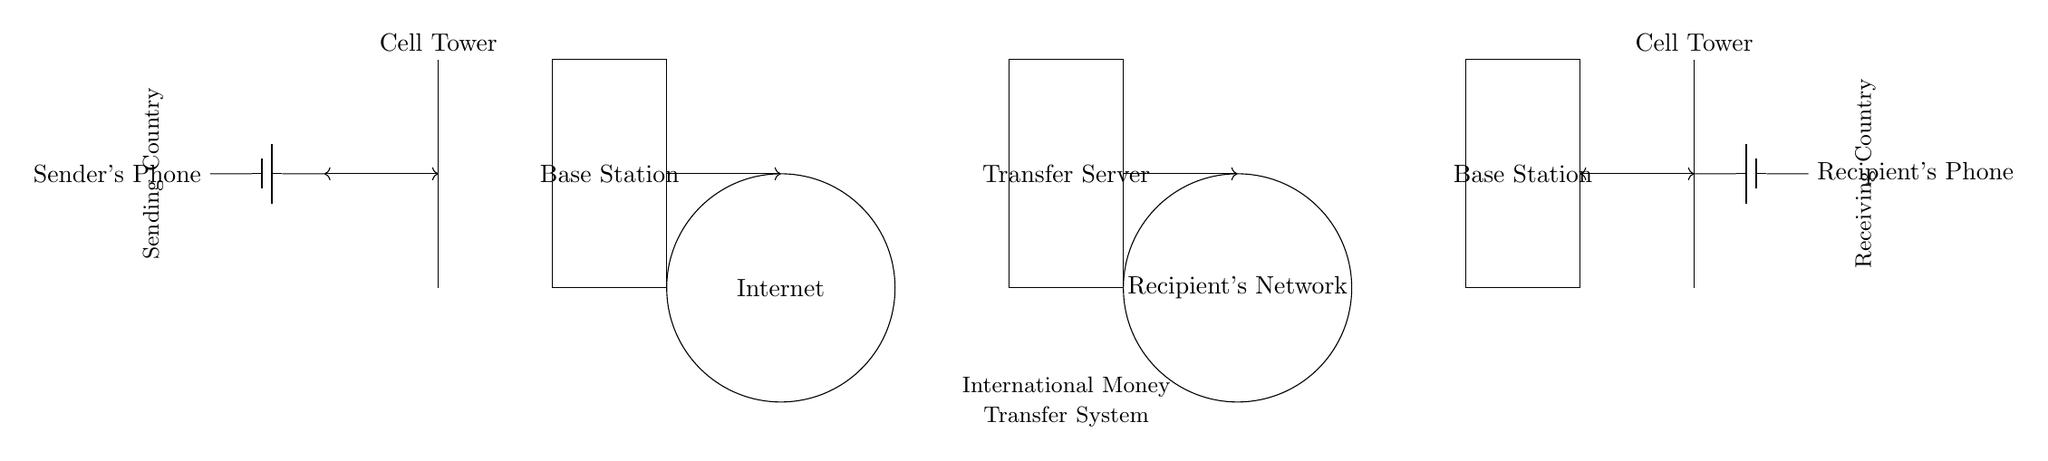What is at the leftmost part of the circuit? The leftmost part of the circuit features the sender's phone connected to a battery, which supplies power for sending signals.
Answer: Sender's Phone What is in the center of the circuit diagram? In the center, there is a base station enclosed in a rectangle, which acts as a pivotal point for relaying signals between the sender and the internet.
Answer: Base Station How many cloud representations are there in the circuit? There are two cloud representations, one for the internet and another for the recipient's network, indicating the flow of data across networks.
Answer: Two What type of connection is shown leading from the base station to the internet? The connection depicted is directed towards the internet, indicated by an arrow, showing the progression of the transferred data.
Answer: Arrow Which component indicates the final step of the transfer to the recipient? The final step to the recipient is indicated by the recipient's phone, which receives the signal after the transfer process is complete.
Answer: Recipient's Phone Why are there two base stations depicted in the diagram? The two base stations represent the local infrastructure in both the sending and receiving countries, necessary for maintaining cellular communication during the process.
Answer: Local infrastructure What kind of signal transfer connection is shown between the sender's phone and the base station? The connection is bidirectional as indicated by the double-headed arrow, allowing for both sending and receiving signals.
Answer: Bidirectional 